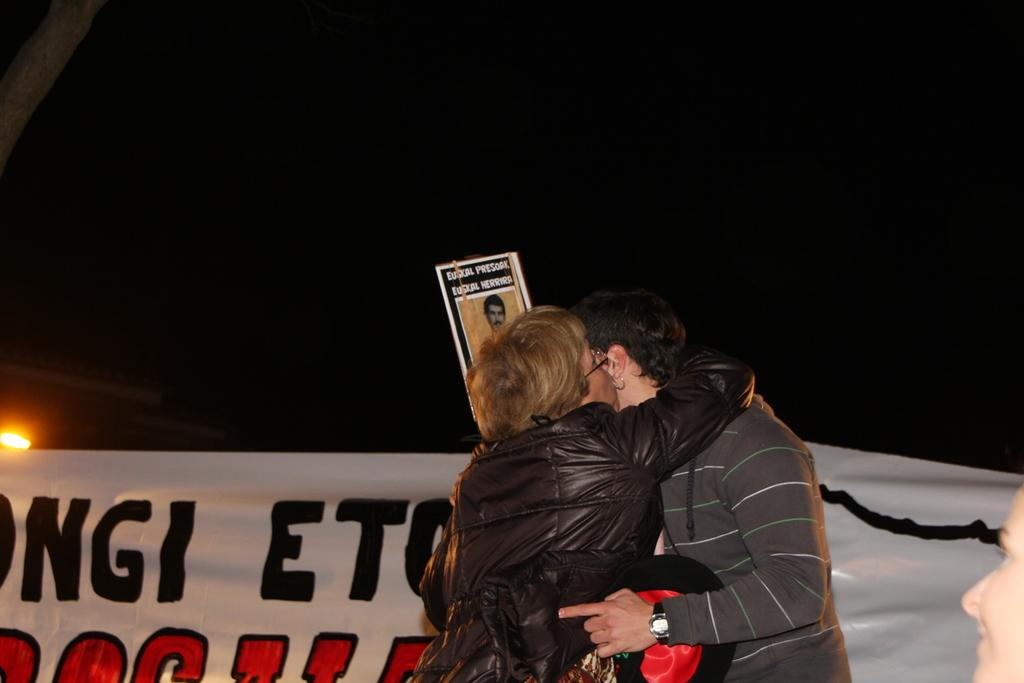How many people are present in the image? There are three people in the image. What can be seen hanging in the image? There is a banner and a poster in the image. Is there any source of light visible in the image? Yes, there is a light in the image. What else can be seen in the image besides the people and the banner? There are some objects in the image. How would you describe the overall lighting in the image? The background of the image is dark. Are there any icicles hanging from the ceiling in the image? There are no icicles present in the image. What type of science experiment is being conducted in the image? There is no science experiment visible in the image. 